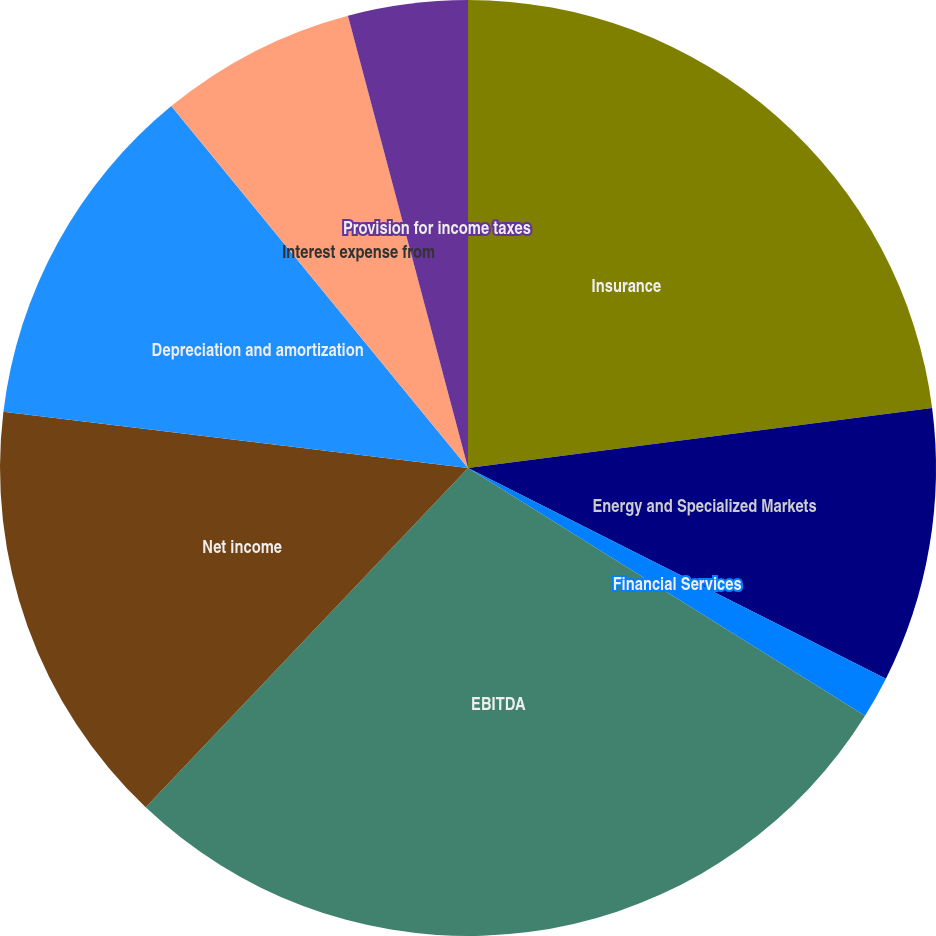Convert chart. <chart><loc_0><loc_0><loc_500><loc_500><pie_chart><fcel>Insurance<fcel>Energy and Specialized Markets<fcel>Financial Services<fcel>EBITDA<fcel>Net income<fcel>Depreciation and amortization<fcel>Interest expense from<fcel>Provision for income taxes<nl><fcel>22.95%<fcel>9.48%<fcel>1.45%<fcel>28.21%<fcel>14.83%<fcel>12.15%<fcel>6.8%<fcel>4.13%<nl></chart> 